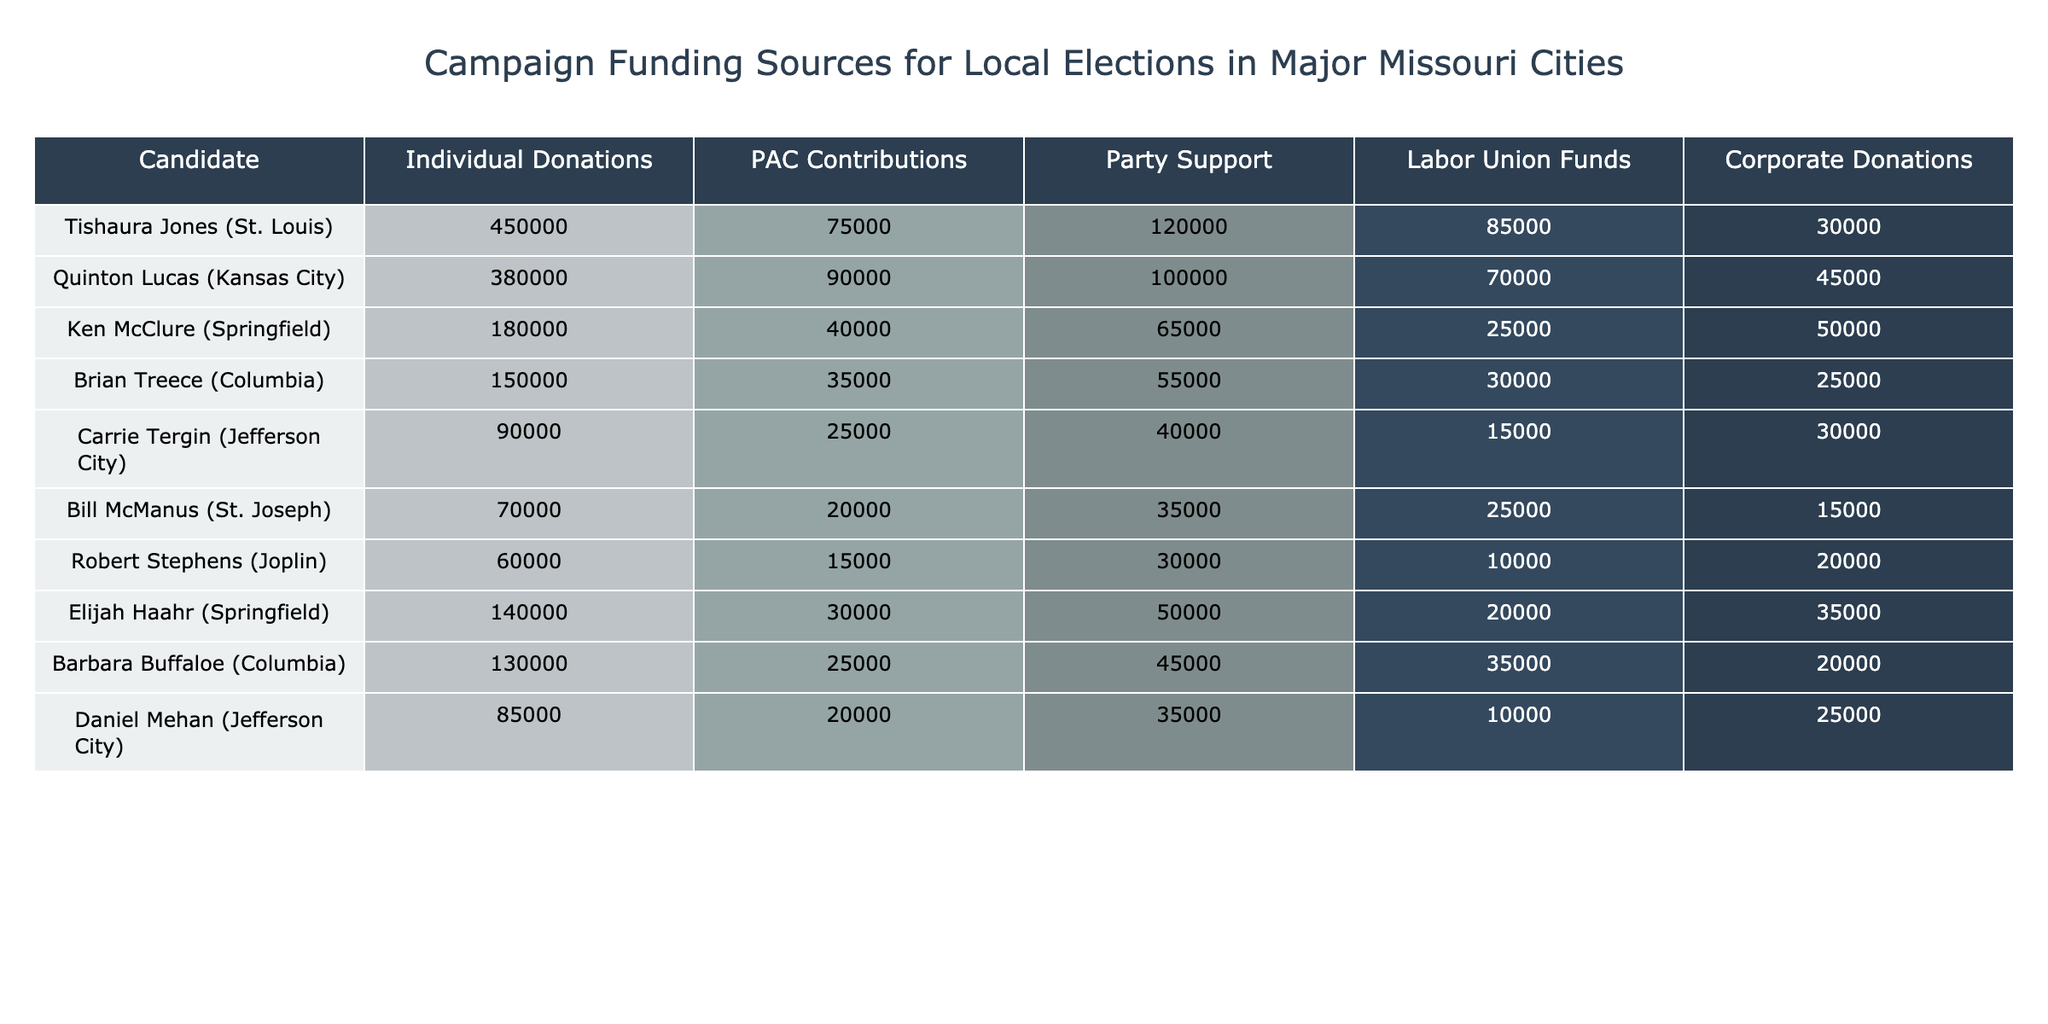What is the total amount of individual donations for Tishaura Jones? According to the table, Tishaura Jones received 450,000 in individual donations.
Answer: 450000 Which candidate received the highest amount in corporate donations? From the table, the candidate with the highest corporate donations is Quinton Lucas, who received 45,000.
Answer: 45000 What is the sum of PAC contributions for all candidates in Columbia? In Columbia, Brian Treece received 35,000 and Barbara Buffaloe received 25,000 in PAC contributions. Adding these gives 35,000 + 25,000 = 60,000.
Answer: 60000 Did any candidate in Jefferson City receive more than 100,000 in individual donations? From the table, the candidates from Jefferson City, Carrie Tergin and Daniel Mehan, received 90,000 and 85,000 respectively, both below 100,000.
Answer: No What is the average amount of labor union funds for candidates in Springfield? In Springfield, Ken McClure received 25,000 and Elijah Haahr received 20,000 in labor union funds. The average is (25,000 + 20,000) / 2 = 22,500.
Answer: 22500 How much total funding support (individual, PAC, party, labor union, and corporate) did Quinton Lucas receive compared to Ken McClure? For Quinton Lucas, the total is 380,000 + 90,000 + 100,000 + 70,000 + 45,000 = 685,000. For Ken McClure, it is 180,000 + 40,000 + 65,000 + 25,000 + 50,000 = 360,000. Quinton Lucas received more, 685,000 vs 360,000.
Answer: Quinton Lucas received more Which city had the least total campaign funding for its candidates? By summing each candidate's total funding: Tishaura Jones (725,000), Quinton Lucas (685,000), Ken McClure (360,000), Brian Treece (230,000), Carrie Tergin (145,000), Bill McManus (119,000), Robert Stephens (116,000), Elijah Haahr (210,000), Barbara Buffaloe (130,000), Daniel Mehan (120,000). The least is Bill McManus from St. Joseph with a total of 119,000.
Answer: St. Joseph Which candidate received the most total funds from party support across all cities? Tishaura Jones received 120,000 in party support, more than others listed.
Answer: 120000 How much more did individual donations contribute to the total for Brian Treece than PAC contributions? Brian Treece's individual donations are 150,000 and PAC contributions are 35,000. The difference is 150,000 - 35,000 = 115,000.
Answer: 115000 Which candidates received more than 50,000 in corporate donations? From the table, only Quinton Lucas (45,000) and Ken McClure (50,000) are listed with more than 50,000. The remaining candidates received less.
Answer: No 